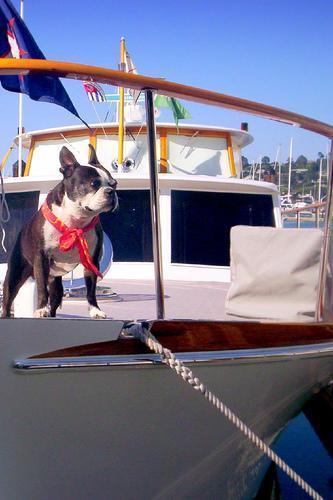How many people are visible in the picture?
Give a very brief answer. 0. 